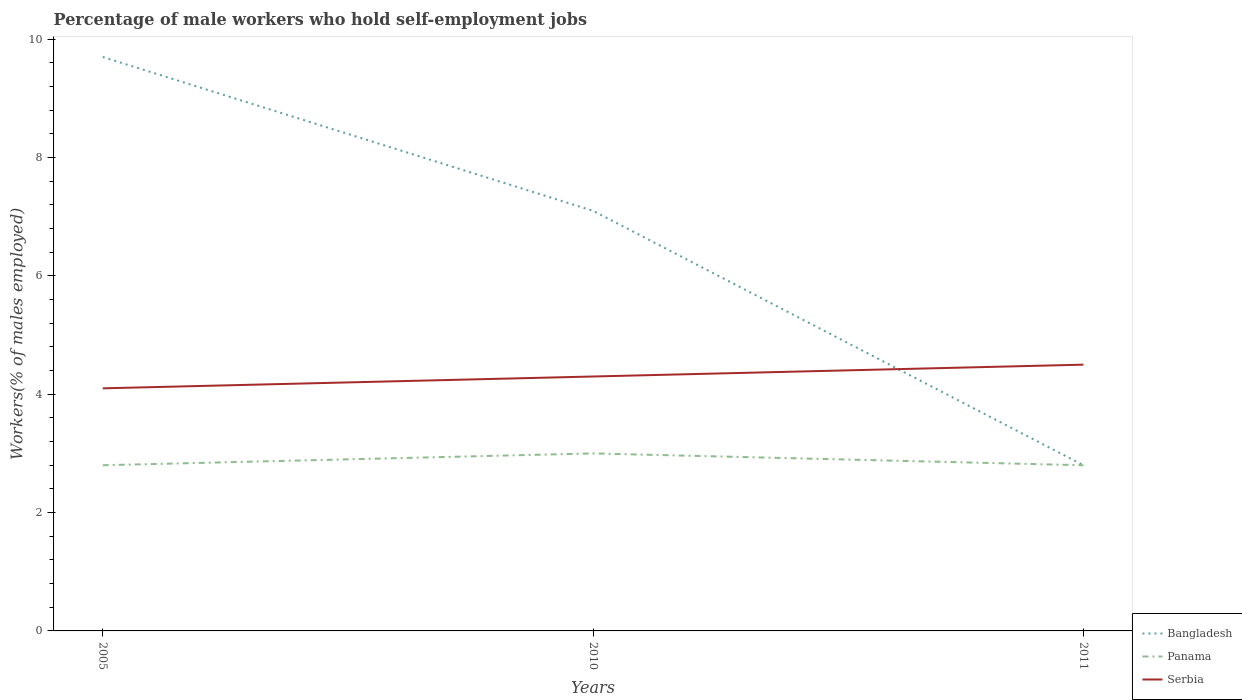Is the number of lines equal to the number of legend labels?
Keep it short and to the point. Yes. Across all years, what is the maximum percentage of self-employed male workers in Serbia?
Offer a terse response. 4.1. What is the total percentage of self-employed male workers in Bangladesh in the graph?
Provide a succinct answer. 6.9. What is the difference between the highest and the second highest percentage of self-employed male workers in Bangladesh?
Offer a terse response. 6.9. Is the percentage of self-employed male workers in Serbia strictly greater than the percentage of self-employed male workers in Panama over the years?
Ensure brevity in your answer.  No. How many lines are there?
Ensure brevity in your answer.  3. What is the difference between two consecutive major ticks on the Y-axis?
Your response must be concise. 2. Does the graph contain any zero values?
Provide a short and direct response. No. Where does the legend appear in the graph?
Your response must be concise. Bottom right. What is the title of the graph?
Give a very brief answer. Percentage of male workers who hold self-employment jobs. What is the label or title of the X-axis?
Ensure brevity in your answer.  Years. What is the label or title of the Y-axis?
Provide a short and direct response. Workers(% of males employed). What is the Workers(% of males employed) in Bangladesh in 2005?
Your answer should be compact. 9.7. What is the Workers(% of males employed) of Panama in 2005?
Give a very brief answer. 2.8. What is the Workers(% of males employed) of Serbia in 2005?
Keep it short and to the point. 4.1. What is the Workers(% of males employed) in Bangladesh in 2010?
Make the answer very short. 7.1. What is the Workers(% of males employed) in Serbia in 2010?
Make the answer very short. 4.3. What is the Workers(% of males employed) in Bangladesh in 2011?
Ensure brevity in your answer.  2.8. What is the Workers(% of males employed) of Panama in 2011?
Keep it short and to the point. 2.8. What is the Workers(% of males employed) in Serbia in 2011?
Provide a short and direct response. 4.5. Across all years, what is the maximum Workers(% of males employed) of Bangladesh?
Provide a succinct answer. 9.7. Across all years, what is the maximum Workers(% of males employed) of Panama?
Ensure brevity in your answer.  3. Across all years, what is the maximum Workers(% of males employed) in Serbia?
Offer a very short reply. 4.5. Across all years, what is the minimum Workers(% of males employed) in Bangladesh?
Offer a terse response. 2.8. Across all years, what is the minimum Workers(% of males employed) of Panama?
Offer a terse response. 2.8. Across all years, what is the minimum Workers(% of males employed) of Serbia?
Offer a very short reply. 4.1. What is the total Workers(% of males employed) in Bangladesh in the graph?
Provide a short and direct response. 19.6. What is the total Workers(% of males employed) of Panama in the graph?
Your answer should be compact. 8.6. What is the difference between the Workers(% of males employed) of Bangladesh in 2005 and that in 2010?
Make the answer very short. 2.6. What is the difference between the Workers(% of males employed) of Panama in 2005 and that in 2010?
Offer a terse response. -0.2. What is the difference between the Workers(% of males employed) in Serbia in 2005 and that in 2010?
Keep it short and to the point. -0.2. What is the difference between the Workers(% of males employed) of Bangladesh in 2005 and that in 2011?
Offer a very short reply. 6.9. What is the difference between the Workers(% of males employed) of Serbia in 2005 and that in 2011?
Offer a terse response. -0.4. What is the difference between the Workers(% of males employed) of Bangladesh in 2010 and that in 2011?
Your response must be concise. 4.3. What is the difference between the Workers(% of males employed) in Panama in 2010 and that in 2011?
Offer a terse response. 0.2. What is the difference between the Workers(% of males employed) in Bangladesh in 2005 and the Workers(% of males employed) in Serbia in 2010?
Your response must be concise. 5.4. What is the difference between the Workers(% of males employed) of Bangladesh in 2005 and the Workers(% of males employed) of Serbia in 2011?
Your answer should be very brief. 5.2. What is the difference between the Workers(% of males employed) in Bangladesh in 2010 and the Workers(% of males employed) in Serbia in 2011?
Give a very brief answer. 2.6. What is the difference between the Workers(% of males employed) of Panama in 2010 and the Workers(% of males employed) of Serbia in 2011?
Ensure brevity in your answer.  -1.5. What is the average Workers(% of males employed) in Bangladesh per year?
Provide a succinct answer. 6.53. What is the average Workers(% of males employed) of Panama per year?
Keep it short and to the point. 2.87. What is the average Workers(% of males employed) of Serbia per year?
Your answer should be very brief. 4.3. In the year 2005, what is the difference between the Workers(% of males employed) in Bangladesh and Workers(% of males employed) in Panama?
Your answer should be compact. 6.9. In the year 2005, what is the difference between the Workers(% of males employed) in Bangladesh and Workers(% of males employed) in Serbia?
Offer a terse response. 5.6. In the year 2010, what is the difference between the Workers(% of males employed) of Bangladesh and Workers(% of males employed) of Panama?
Your answer should be compact. 4.1. In the year 2010, what is the difference between the Workers(% of males employed) of Panama and Workers(% of males employed) of Serbia?
Offer a terse response. -1.3. In the year 2011, what is the difference between the Workers(% of males employed) in Panama and Workers(% of males employed) in Serbia?
Provide a short and direct response. -1.7. What is the ratio of the Workers(% of males employed) of Bangladesh in 2005 to that in 2010?
Make the answer very short. 1.37. What is the ratio of the Workers(% of males employed) in Serbia in 2005 to that in 2010?
Give a very brief answer. 0.95. What is the ratio of the Workers(% of males employed) in Bangladesh in 2005 to that in 2011?
Provide a succinct answer. 3.46. What is the ratio of the Workers(% of males employed) of Serbia in 2005 to that in 2011?
Your answer should be compact. 0.91. What is the ratio of the Workers(% of males employed) of Bangladesh in 2010 to that in 2011?
Offer a very short reply. 2.54. What is the ratio of the Workers(% of males employed) in Panama in 2010 to that in 2011?
Keep it short and to the point. 1.07. What is the ratio of the Workers(% of males employed) of Serbia in 2010 to that in 2011?
Provide a succinct answer. 0.96. What is the difference between the highest and the second highest Workers(% of males employed) in Bangladesh?
Ensure brevity in your answer.  2.6. What is the difference between the highest and the second highest Workers(% of males employed) in Panama?
Your answer should be compact. 0.2. What is the difference between the highest and the lowest Workers(% of males employed) of Bangladesh?
Make the answer very short. 6.9. What is the difference between the highest and the lowest Workers(% of males employed) of Panama?
Keep it short and to the point. 0.2. What is the difference between the highest and the lowest Workers(% of males employed) of Serbia?
Your answer should be very brief. 0.4. 